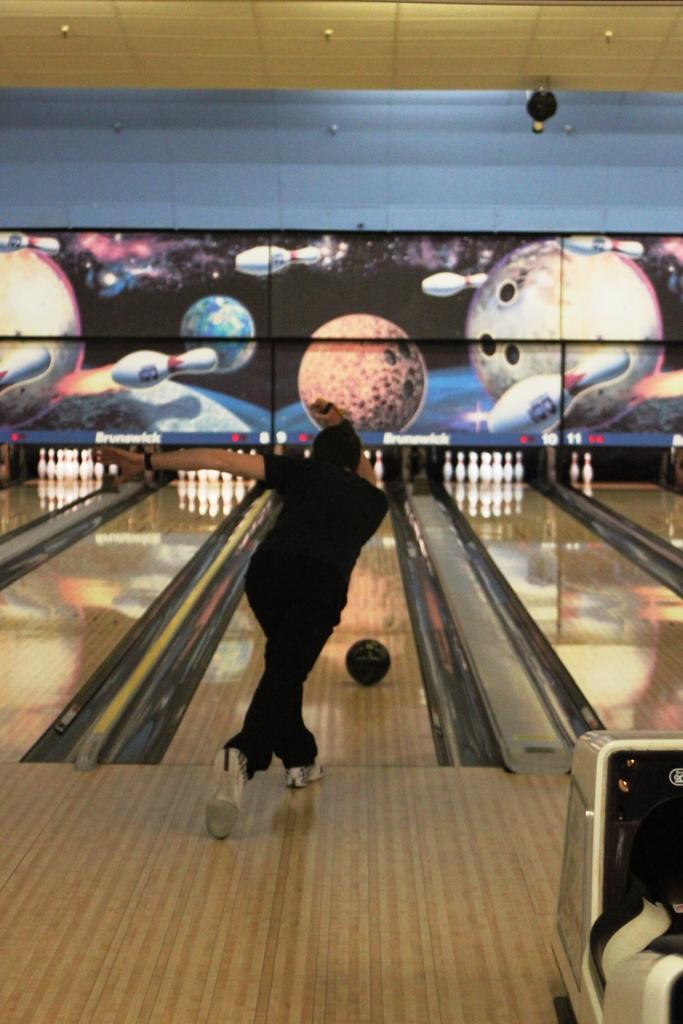How would you summarize this image in a sentence or two? In the foreground of this image, there is a man bending on the wooden floor. On the right, there is an object. In the background, there is the area of bowling ball game. At the top, there is the ceiling. 